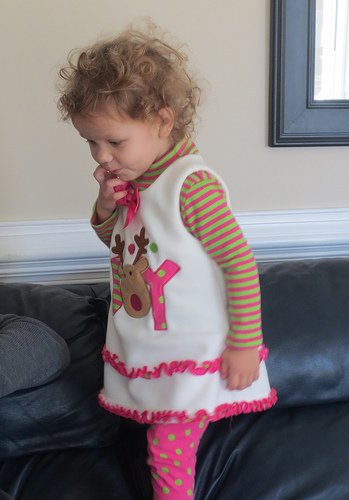<image>
Can you confirm if the striped shirt is under the jumper? Yes. The striped shirt is positioned underneath the jumper, with the jumper above it in the vertical space. Is there a wall above the bed? No. The wall is not positioned above the bed. The vertical arrangement shows a different relationship. 